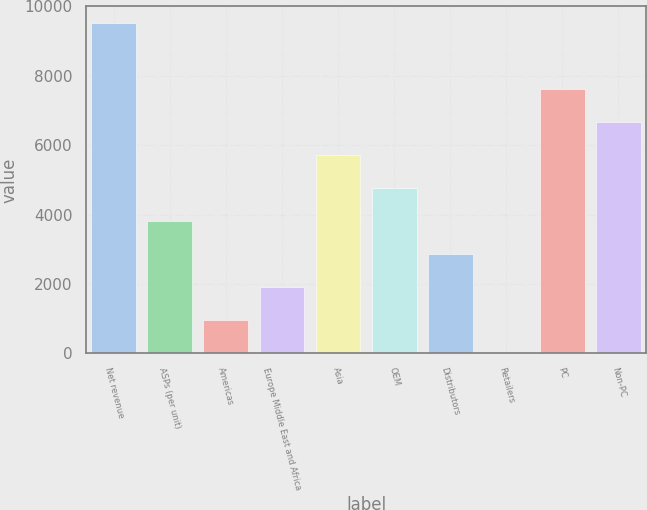Convert chart. <chart><loc_0><loc_0><loc_500><loc_500><bar_chart><fcel>Net revenue<fcel>ASPs (per unit)<fcel>Americas<fcel>Europe Middle East and Africa<fcel>Asia<fcel>OEM<fcel>Distributors<fcel>Retailers<fcel>PC<fcel>Non-PC<nl><fcel>9526<fcel>3821.8<fcel>969.7<fcel>1920.4<fcel>5723.2<fcel>4772.5<fcel>2871.1<fcel>19<fcel>7624.6<fcel>6673.9<nl></chart> 